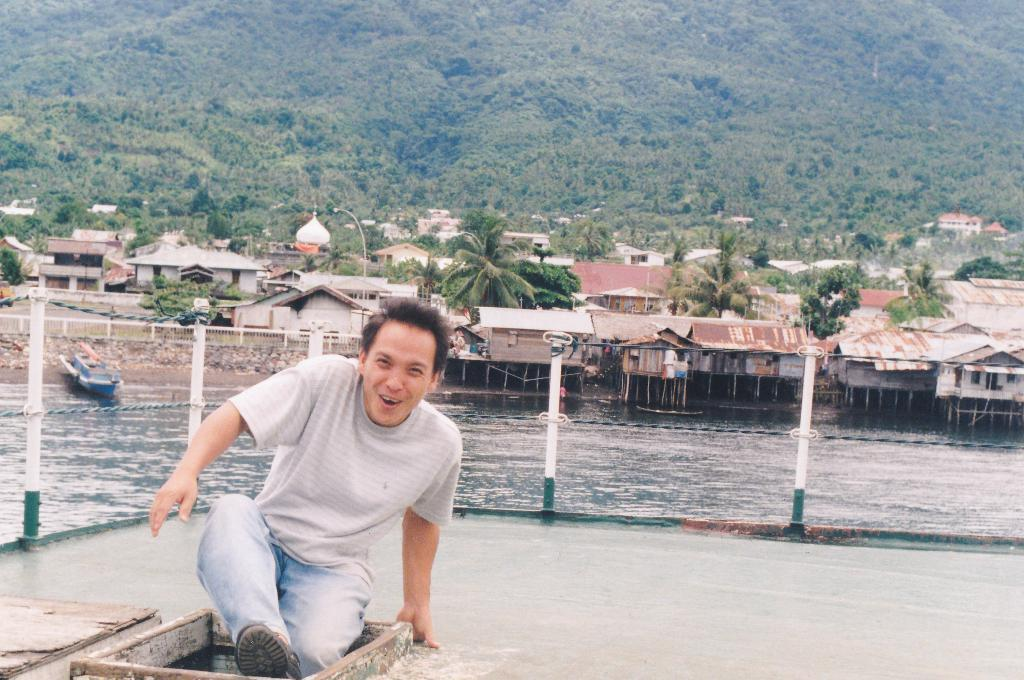What type of structures can be seen in the image? There are houses in the image. What natural elements are present in the image? There are trees and a lake visible in the image. Can you describe the person in the image? There is a person visible in the foreground. What geographical feature is visible at the top of the image? A hill is visible at the top of the image. What man-made objects can be seen in the middle of the image? There are poles in the middle of the image. What type of beef is being stored in the jar in the image? There is no beef or jar present in the image. Where is the pocket located on the person in the image? There is no pocket visible on the person in the image. 